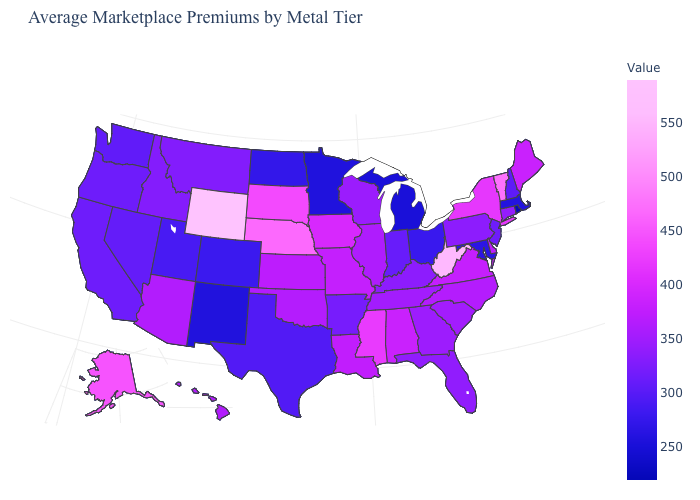Which states have the lowest value in the USA?
Be succinct. Rhode Island. Does the map have missing data?
Write a very short answer. No. Does Minnesota have a lower value than Louisiana?
Give a very brief answer. Yes. Does Florida have a higher value than Wyoming?
Answer briefly. No. Among the states that border New Mexico , does Texas have the highest value?
Be succinct. No. Does Rhode Island have the lowest value in the USA?
Concise answer only. Yes. Is the legend a continuous bar?
Write a very short answer. Yes. 